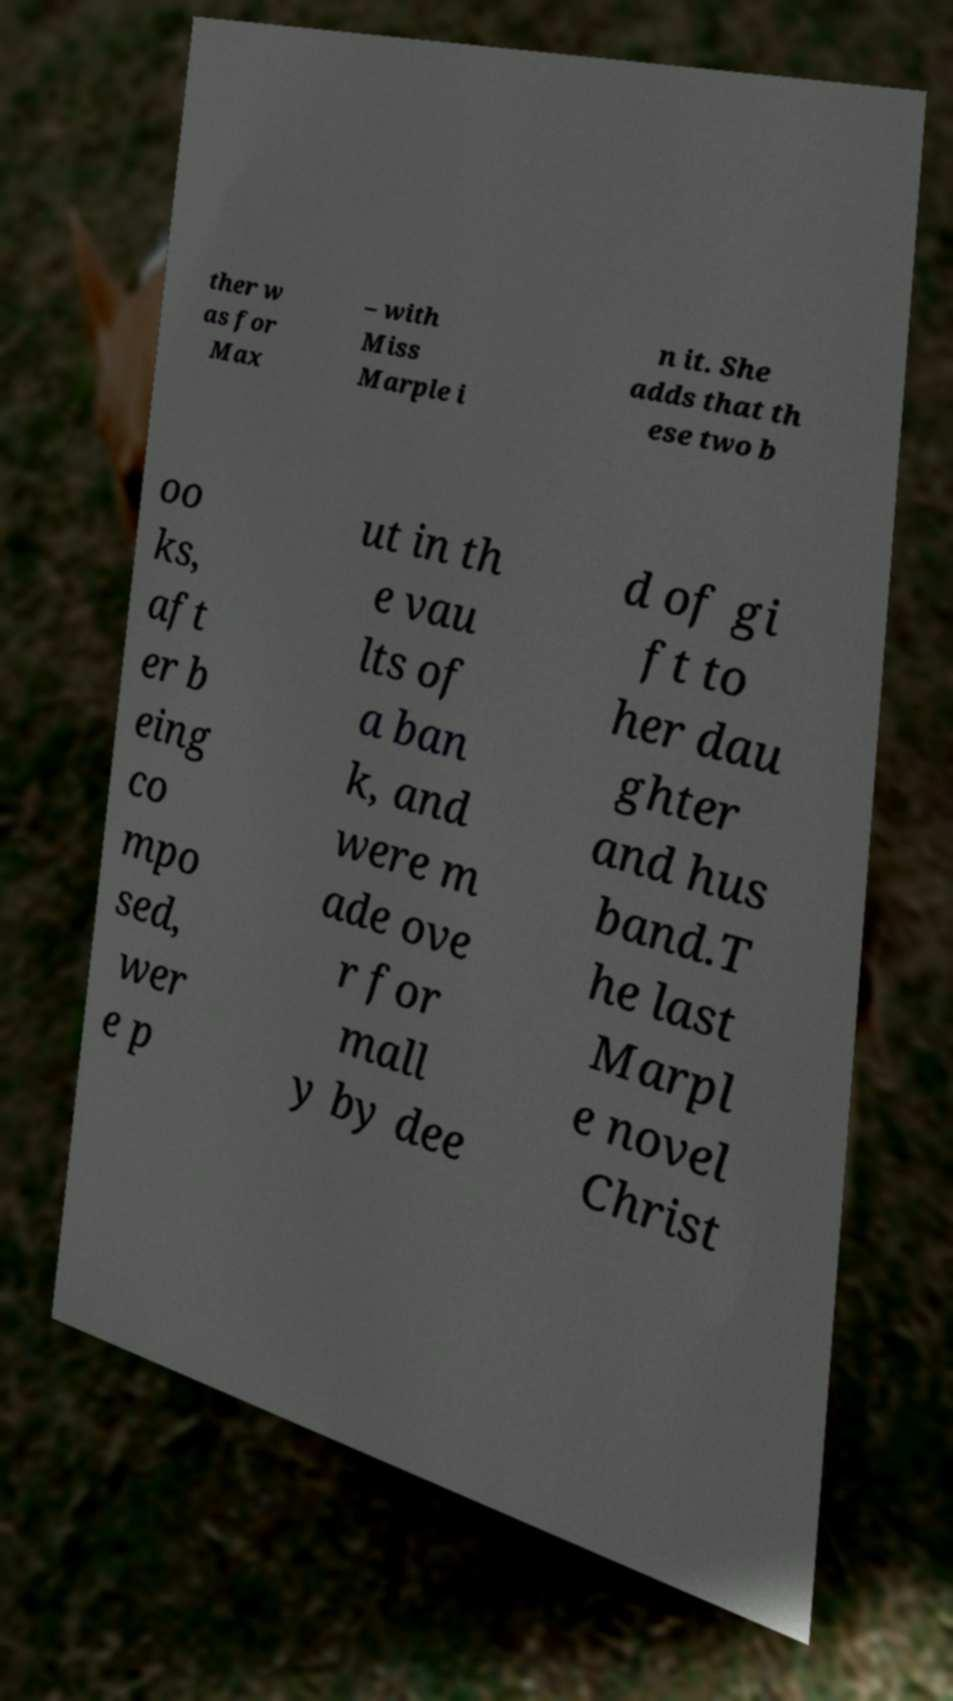Please read and relay the text visible in this image. What does it say? ther w as for Max – with Miss Marple i n it. She adds that th ese two b oo ks, aft er b eing co mpo sed, wer e p ut in th e vau lts of a ban k, and were m ade ove r for mall y by dee d of gi ft to her dau ghter and hus band.T he last Marpl e novel Christ 